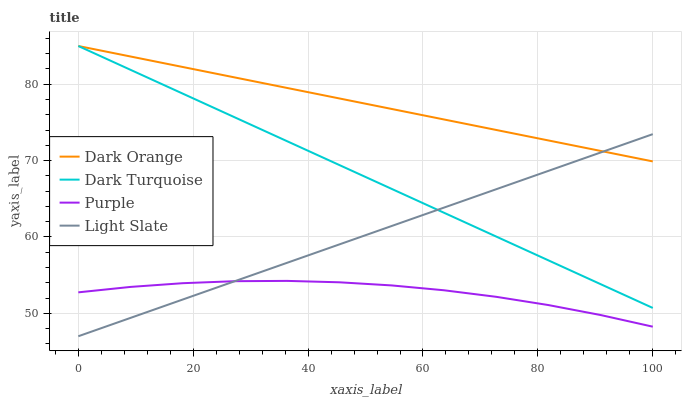Does Purple have the minimum area under the curve?
Answer yes or no. Yes. Does Dark Orange have the maximum area under the curve?
Answer yes or no. Yes. Does Light Slate have the minimum area under the curve?
Answer yes or no. No. Does Light Slate have the maximum area under the curve?
Answer yes or no. No. Is Light Slate the smoothest?
Answer yes or no. Yes. Is Purple the roughest?
Answer yes or no. Yes. Is Dark Orange the smoothest?
Answer yes or no. No. Is Dark Orange the roughest?
Answer yes or no. No. Does Light Slate have the lowest value?
Answer yes or no. Yes. Does Dark Orange have the lowest value?
Answer yes or no. No. Does Dark Turquoise have the highest value?
Answer yes or no. Yes. Does Light Slate have the highest value?
Answer yes or no. No. Is Purple less than Dark Orange?
Answer yes or no. Yes. Is Dark Orange greater than Purple?
Answer yes or no. Yes. Does Dark Orange intersect Light Slate?
Answer yes or no. Yes. Is Dark Orange less than Light Slate?
Answer yes or no. No. Is Dark Orange greater than Light Slate?
Answer yes or no. No. Does Purple intersect Dark Orange?
Answer yes or no. No. 